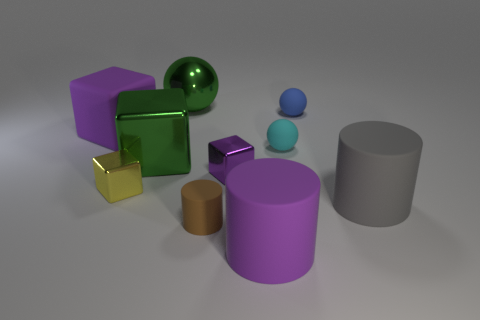Subtract all gray rubber cylinders. How many cylinders are left? 2 Subtract 2 cubes. How many cubes are left? 2 Subtract all purple cylinders. How many cylinders are left? 2 Subtract 0 yellow spheres. How many objects are left? 10 Subtract all cylinders. How many objects are left? 7 Subtract all purple cylinders. Subtract all brown cubes. How many cylinders are left? 2 Subtract all purple cylinders. How many brown balls are left? 0 Subtract all large cubes. Subtract all tiny brown cylinders. How many objects are left? 7 Add 6 matte cubes. How many matte cubes are left? 7 Add 7 big rubber cylinders. How many big rubber cylinders exist? 9 